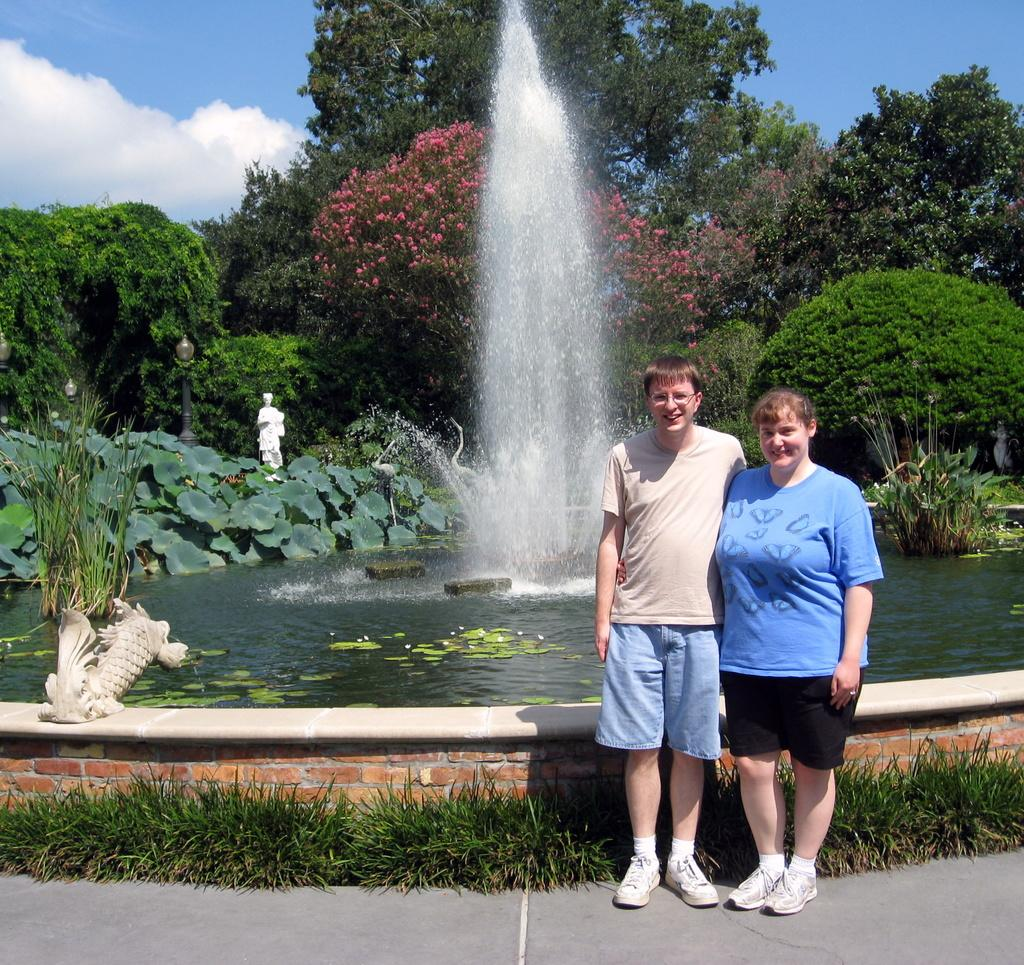How many people are in the image? There are two persons standing and smiling in the image. What can be seen in the background of the image? The sky is visible in the background of the image. What type of natural environment is present in the image? There is grass, plants, and trees in the image. What architectural or artistic features can be seen in the image? There is a water fountain, sculptures, and trees in the image. What type of knowledge is being shared between the two persons in the image? There is no indication in the image that the two persons are sharing any knowledge. 